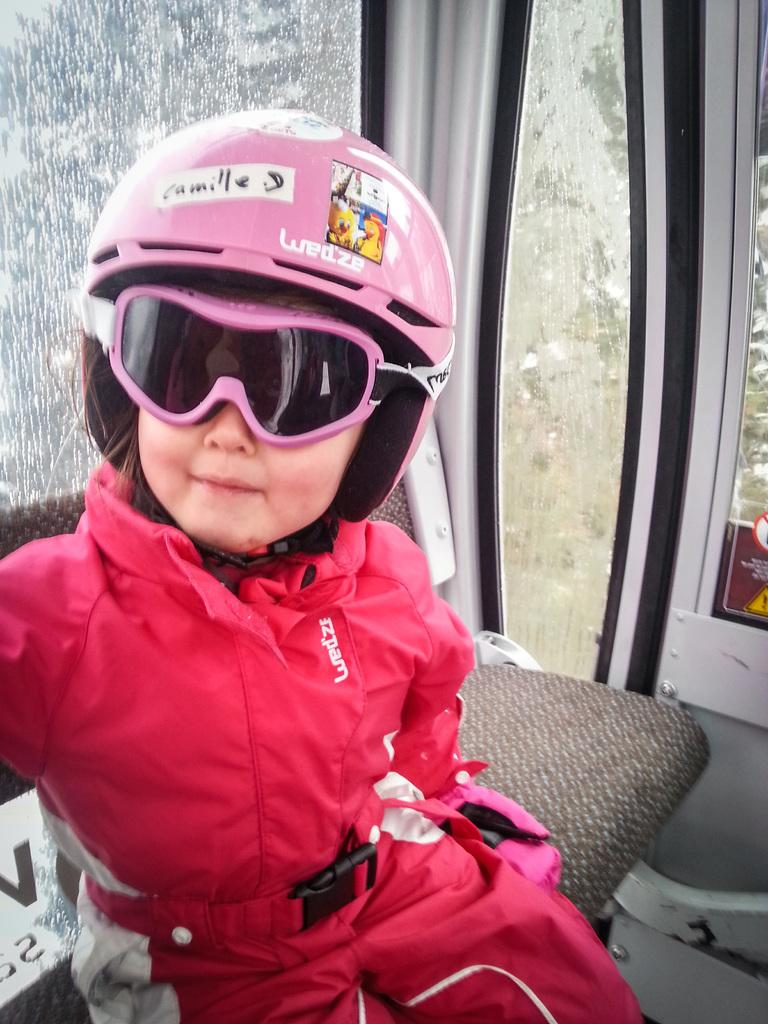Who is the main subject in the image? There is a girl in the image. What is the girl wearing? The girl is wearing a pink dress, pink shades, and a pink helmet. What is written on the helmet? There is writing on the helmet. What type of animal can be seen biting the girl's dress in the image? There is no animal present in the image, and the girl's dress is not being bitten by any creature. 